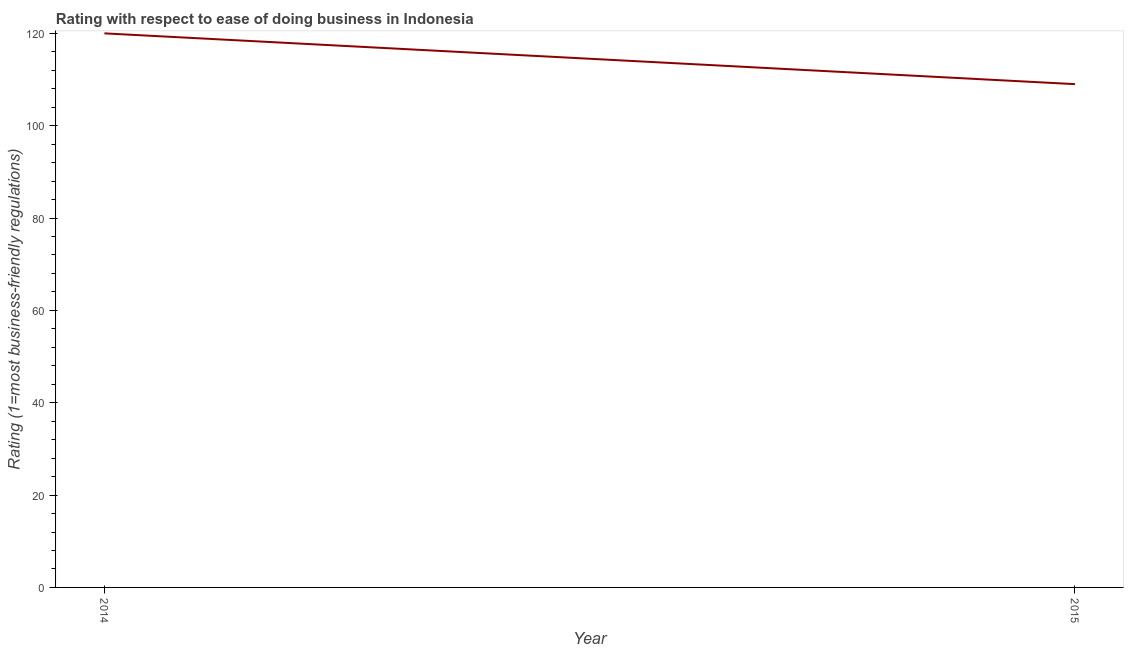What is the ease of doing business index in 2014?
Provide a short and direct response. 120. Across all years, what is the maximum ease of doing business index?
Keep it short and to the point. 120. Across all years, what is the minimum ease of doing business index?
Offer a very short reply. 109. In which year was the ease of doing business index minimum?
Give a very brief answer. 2015. What is the sum of the ease of doing business index?
Offer a terse response. 229. What is the difference between the ease of doing business index in 2014 and 2015?
Give a very brief answer. 11. What is the average ease of doing business index per year?
Make the answer very short. 114.5. What is the median ease of doing business index?
Keep it short and to the point. 114.5. In how many years, is the ease of doing business index greater than 80 ?
Give a very brief answer. 2. Do a majority of the years between 2015 and 2014 (inclusive) have ease of doing business index greater than 44 ?
Keep it short and to the point. No. What is the ratio of the ease of doing business index in 2014 to that in 2015?
Keep it short and to the point. 1.1. How many lines are there?
Provide a succinct answer. 1. How many years are there in the graph?
Ensure brevity in your answer.  2. What is the title of the graph?
Ensure brevity in your answer.  Rating with respect to ease of doing business in Indonesia. What is the label or title of the Y-axis?
Provide a succinct answer. Rating (1=most business-friendly regulations). What is the Rating (1=most business-friendly regulations) in 2014?
Make the answer very short. 120. What is the Rating (1=most business-friendly regulations) of 2015?
Offer a very short reply. 109. What is the difference between the Rating (1=most business-friendly regulations) in 2014 and 2015?
Offer a very short reply. 11. What is the ratio of the Rating (1=most business-friendly regulations) in 2014 to that in 2015?
Give a very brief answer. 1.1. 